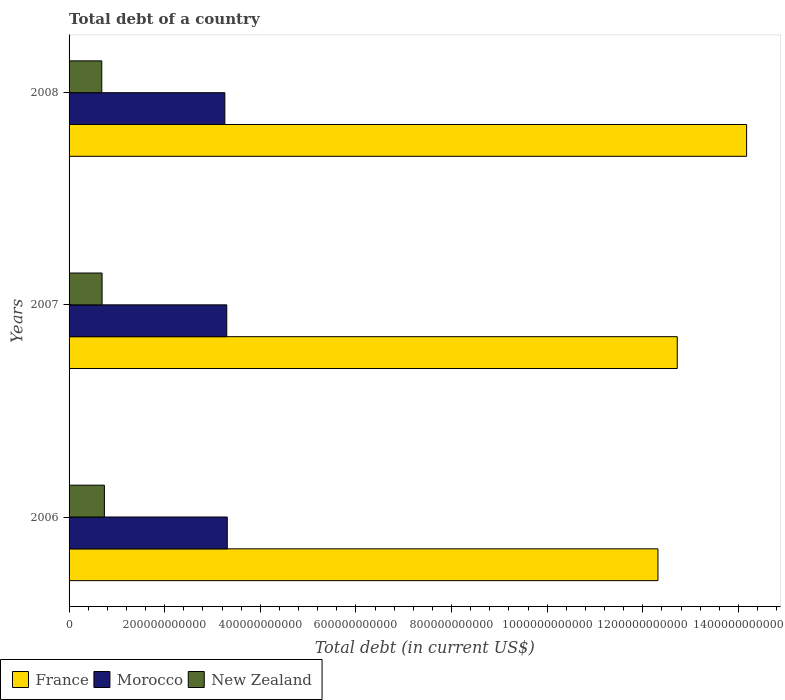How many groups of bars are there?
Your answer should be very brief. 3. Are the number of bars per tick equal to the number of legend labels?
Offer a terse response. Yes. How many bars are there on the 1st tick from the top?
Provide a succinct answer. 3. How many bars are there on the 2nd tick from the bottom?
Ensure brevity in your answer.  3. What is the label of the 1st group of bars from the top?
Your answer should be very brief. 2008. In how many cases, is the number of bars for a given year not equal to the number of legend labels?
Offer a terse response. 0. What is the debt in New Zealand in 2006?
Your answer should be compact. 7.39e+1. Across all years, what is the maximum debt in France?
Your response must be concise. 1.42e+12. Across all years, what is the minimum debt in France?
Provide a short and direct response. 1.23e+12. In which year was the debt in Morocco maximum?
Give a very brief answer. 2006. In which year was the debt in Morocco minimum?
Keep it short and to the point. 2008. What is the total debt in Morocco in the graph?
Ensure brevity in your answer.  9.87e+11. What is the difference between the debt in New Zealand in 2006 and that in 2007?
Offer a terse response. 4.86e+09. What is the difference between the debt in Morocco in 2008 and the debt in France in 2007?
Your answer should be compact. -9.46e+11. What is the average debt in New Zealand per year?
Offer a terse response. 7.04e+1. In the year 2008, what is the difference between the debt in New Zealand and debt in France?
Your response must be concise. -1.35e+12. In how many years, is the debt in Morocco greater than 560000000000 US$?
Your answer should be compact. 0. What is the ratio of the debt in New Zealand in 2006 to that in 2008?
Your answer should be compact. 1.08. What is the difference between the highest and the second highest debt in New Zealand?
Keep it short and to the point. 4.86e+09. What is the difference between the highest and the lowest debt in France?
Offer a terse response. 1.85e+11. In how many years, is the debt in Morocco greater than the average debt in Morocco taken over all years?
Your answer should be compact. 2. What does the 1st bar from the top in 2008 represents?
Ensure brevity in your answer.  New Zealand. How many years are there in the graph?
Offer a very short reply. 3. What is the difference between two consecutive major ticks on the X-axis?
Offer a very short reply. 2.00e+11. Does the graph contain any zero values?
Your answer should be very brief. No. Does the graph contain grids?
Your answer should be very brief. No. What is the title of the graph?
Your answer should be compact. Total debt of a country. Does "El Salvador" appear as one of the legend labels in the graph?
Make the answer very short. No. What is the label or title of the X-axis?
Keep it short and to the point. Total debt (in current US$). What is the label or title of the Y-axis?
Give a very brief answer. Years. What is the Total debt (in current US$) of France in 2006?
Provide a succinct answer. 1.23e+12. What is the Total debt (in current US$) of Morocco in 2006?
Your response must be concise. 3.31e+11. What is the Total debt (in current US$) of New Zealand in 2006?
Offer a very short reply. 7.39e+1. What is the Total debt (in current US$) of France in 2007?
Provide a short and direct response. 1.27e+12. What is the Total debt (in current US$) in Morocco in 2007?
Your answer should be very brief. 3.30e+11. What is the Total debt (in current US$) in New Zealand in 2007?
Provide a succinct answer. 6.90e+1. What is the Total debt (in current US$) in France in 2008?
Ensure brevity in your answer.  1.42e+12. What is the Total debt (in current US$) of Morocco in 2008?
Ensure brevity in your answer.  3.26e+11. What is the Total debt (in current US$) in New Zealand in 2008?
Your response must be concise. 6.84e+1. Across all years, what is the maximum Total debt (in current US$) in France?
Offer a terse response. 1.42e+12. Across all years, what is the maximum Total debt (in current US$) of Morocco?
Keep it short and to the point. 3.31e+11. Across all years, what is the maximum Total debt (in current US$) of New Zealand?
Your answer should be very brief. 7.39e+1. Across all years, what is the minimum Total debt (in current US$) of France?
Ensure brevity in your answer.  1.23e+12. Across all years, what is the minimum Total debt (in current US$) of Morocco?
Your answer should be very brief. 3.26e+11. Across all years, what is the minimum Total debt (in current US$) of New Zealand?
Provide a succinct answer. 6.84e+1. What is the total Total debt (in current US$) of France in the graph?
Offer a terse response. 3.92e+12. What is the total Total debt (in current US$) in Morocco in the graph?
Offer a very short reply. 9.87e+11. What is the total Total debt (in current US$) in New Zealand in the graph?
Give a very brief answer. 2.11e+11. What is the difference between the Total debt (in current US$) of France in 2006 and that in 2007?
Make the answer very short. -4.04e+1. What is the difference between the Total debt (in current US$) of Morocco in 2006 and that in 2007?
Your answer should be compact. 1.06e+09. What is the difference between the Total debt (in current US$) in New Zealand in 2006 and that in 2007?
Offer a very short reply. 4.86e+09. What is the difference between the Total debt (in current US$) of France in 2006 and that in 2008?
Offer a terse response. -1.85e+11. What is the difference between the Total debt (in current US$) of Morocco in 2006 and that in 2008?
Make the answer very short. 5.08e+09. What is the difference between the Total debt (in current US$) of New Zealand in 2006 and that in 2008?
Make the answer very short. 5.51e+09. What is the difference between the Total debt (in current US$) in France in 2007 and that in 2008?
Provide a succinct answer. -1.45e+11. What is the difference between the Total debt (in current US$) of Morocco in 2007 and that in 2008?
Make the answer very short. 4.02e+09. What is the difference between the Total debt (in current US$) of New Zealand in 2007 and that in 2008?
Your response must be concise. 6.55e+08. What is the difference between the Total debt (in current US$) in France in 2006 and the Total debt (in current US$) in Morocco in 2007?
Ensure brevity in your answer.  9.02e+11. What is the difference between the Total debt (in current US$) of France in 2006 and the Total debt (in current US$) of New Zealand in 2007?
Give a very brief answer. 1.16e+12. What is the difference between the Total debt (in current US$) of Morocco in 2006 and the Total debt (in current US$) of New Zealand in 2007?
Your answer should be compact. 2.62e+11. What is the difference between the Total debt (in current US$) in France in 2006 and the Total debt (in current US$) in Morocco in 2008?
Your answer should be compact. 9.06e+11. What is the difference between the Total debt (in current US$) of France in 2006 and the Total debt (in current US$) of New Zealand in 2008?
Keep it short and to the point. 1.16e+12. What is the difference between the Total debt (in current US$) of Morocco in 2006 and the Total debt (in current US$) of New Zealand in 2008?
Make the answer very short. 2.63e+11. What is the difference between the Total debt (in current US$) in France in 2007 and the Total debt (in current US$) in Morocco in 2008?
Make the answer very short. 9.46e+11. What is the difference between the Total debt (in current US$) in France in 2007 and the Total debt (in current US$) in New Zealand in 2008?
Make the answer very short. 1.20e+12. What is the difference between the Total debt (in current US$) in Morocco in 2007 and the Total debt (in current US$) in New Zealand in 2008?
Offer a very short reply. 2.61e+11. What is the average Total debt (in current US$) in France per year?
Ensure brevity in your answer.  1.31e+12. What is the average Total debt (in current US$) in Morocco per year?
Your answer should be compact. 3.29e+11. What is the average Total debt (in current US$) in New Zealand per year?
Offer a very short reply. 7.04e+1. In the year 2006, what is the difference between the Total debt (in current US$) in France and Total debt (in current US$) in Morocco?
Provide a succinct answer. 9.01e+11. In the year 2006, what is the difference between the Total debt (in current US$) of France and Total debt (in current US$) of New Zealand?
Offer a very short reply. 1.16e+12. In the year 2006, what is the difference between the Total debt (in current US$) in Morocco and Total debt (in current US$) in New Zealand?
Ensure brevity in your answer.  2.57e+11. In the year 2007, what is the difference between the Total debt (in current US$) of France and Total debt (in current US$) of Morocco?
Your answer should be very brief. 9.42e+11. In the year 2007, what is the difference between the Total debt (in current US$) in France and Total debt (in current US$) in New Zealand?
Your response must be concise. 1.20e+12. In the year 2007, what is the difference between the Total debt (in current US$) of Morocco and Total debt (in current US$) of New Zealand?
Your answer should be very brief. 2.61e+11. In the year 2008, what is the difference between the Total debt (in current US$) of France and Total debt (in current US$) of Morocco?
Keep it short and to the point. 1.09e+12. In the year 2008, what is the difference between the Total debt (in current US$) in France and Total debt (in current US$) in New Zealand?
Give a very brief answer. 1.35e+12. In the year 2008, what is the difference between the Total debt (in current US$) of Morocco and Total debt (in current US$) of New Zealand?
Your response must be concise. 2.57e+11. What is the ratio of the Total debt (in current US$) in France in 2006 to that in 2007?
Offer a terse response. 0.97. What is the ratio of the Total debt (in current US$) of New Zealand in 2006 to that in 2007?
Provide a succinct answer. 1.07. What is the ratio of the Total debt (in current US$) of France in 2006 to that in 2008?
Give a very brief answer. 0.87. What is the ratio of the Total debt (in current US$) of Morocco in 2006 to that in 2008?
Ensure brevity in your answer.  1.02. What is the ratio of the Total debt (in current US$) in New Zealand in 2006 to that in 2008?
Provide a succinct answer. 1.08. What is the ratio of the Total debt (in current US$) in France in 2007 to that in 2008?
Offer a terse response. 0.9. What is the ratio of the Total debt (in current US$) of Morocco in 2007 to that in 2008?
Keep it short and to the point. 1.01. What is the ratio of the Total debt (in current US$) of New Zealand in 2007 to that in 2008?
Ensure brevity in your answer.  1.01. What is the difference between the highest and the second highest Total debt (in current US$) of France?
Your response must be concise. 1.45e+11. What is the difference between the highest and the second highest Total debt (in current US$) in Morocco?
Give a very brief answer. 1.06e+09. What is the difference between the highest and the second highest Total debt (in current US$) of New Zealand?
Your response must be concise. 4.86e+09. What is the difference between the highest and the lowest Total debt (in current US$) of France?
Provide a short and direct response. 1.85e+11. What is the difference between the highest and the lowest Total debt (in current US$) in Morocco?
Make the answer very short. 5.08e+09. What is the difference between the highest and the lowest Total debt (in current US$) in New Zealand?
Provide a short and direct response. 5.51e+09. 